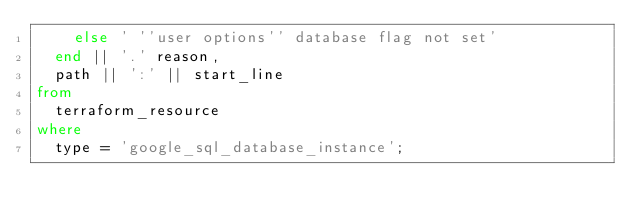Convert code to text. <code><loc_0><loc_0><loc_500><loc_500><_SQL_>    else ' ''user options'' database flag not set'
  end || '.' reason,
  path || ':' || start_line
from
  terraform_resource
where
  type = 'google_sql_database_instance';</code> 